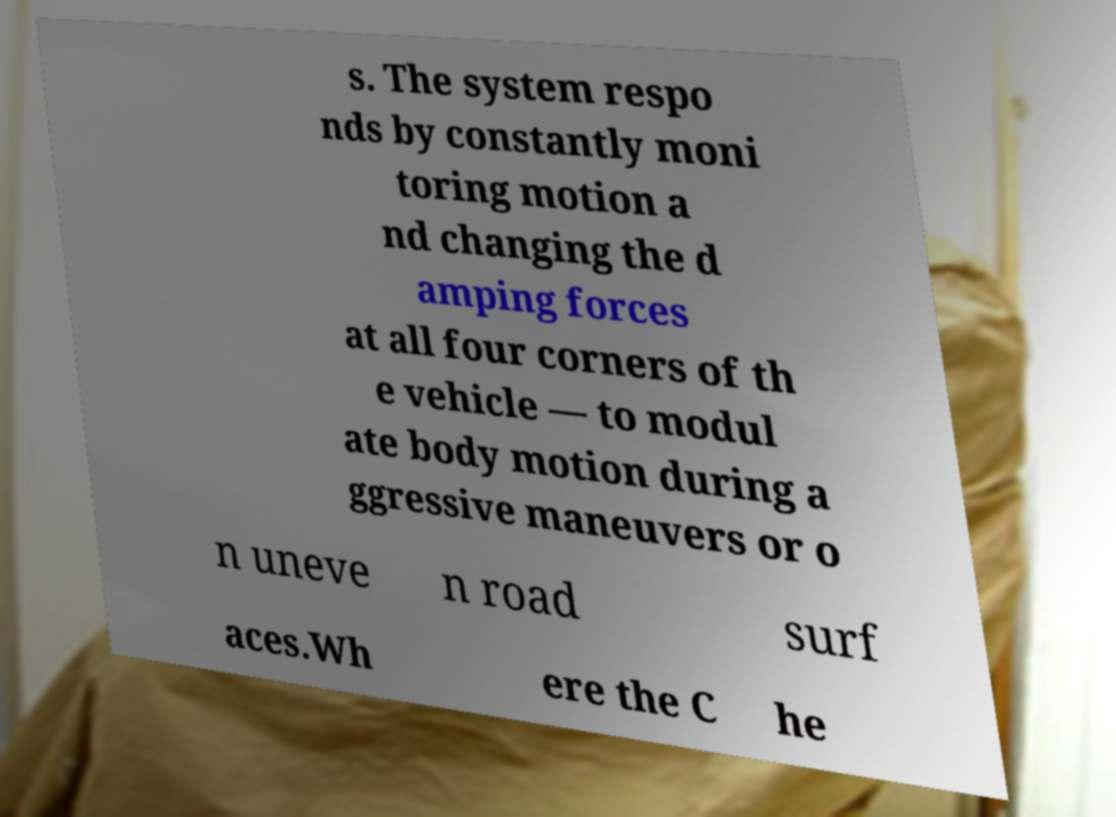Please identify and transcribe the text found in this image. s. The system respo nds by constantly moni toring motion a nd changing the d amping forces at all four corners of th e vehicle — to modul ate body motion during a ggressive maneuvers or o n uneve n road surf aces.Wh ere the C he 